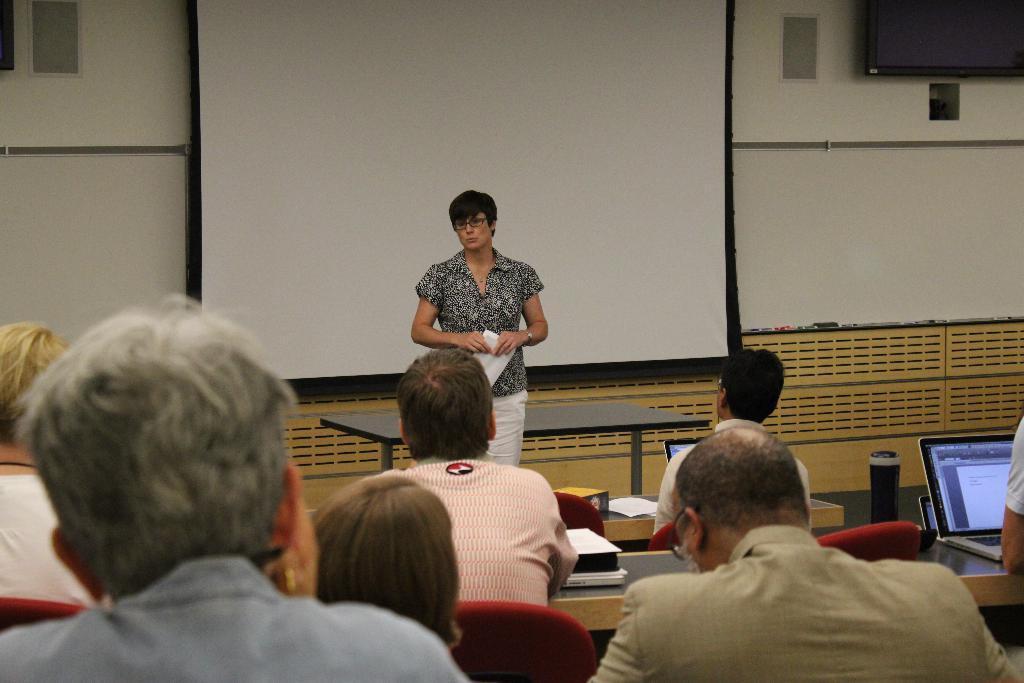Please provide a concise description of this image. The picture is taken in a room. In the foreground of the picture there are people, chairs, benches, books, laptops and bottle. In the center of the picture there is a woman and table. In the background there is projector screen. On the top right there is television. The wall is painted white. 